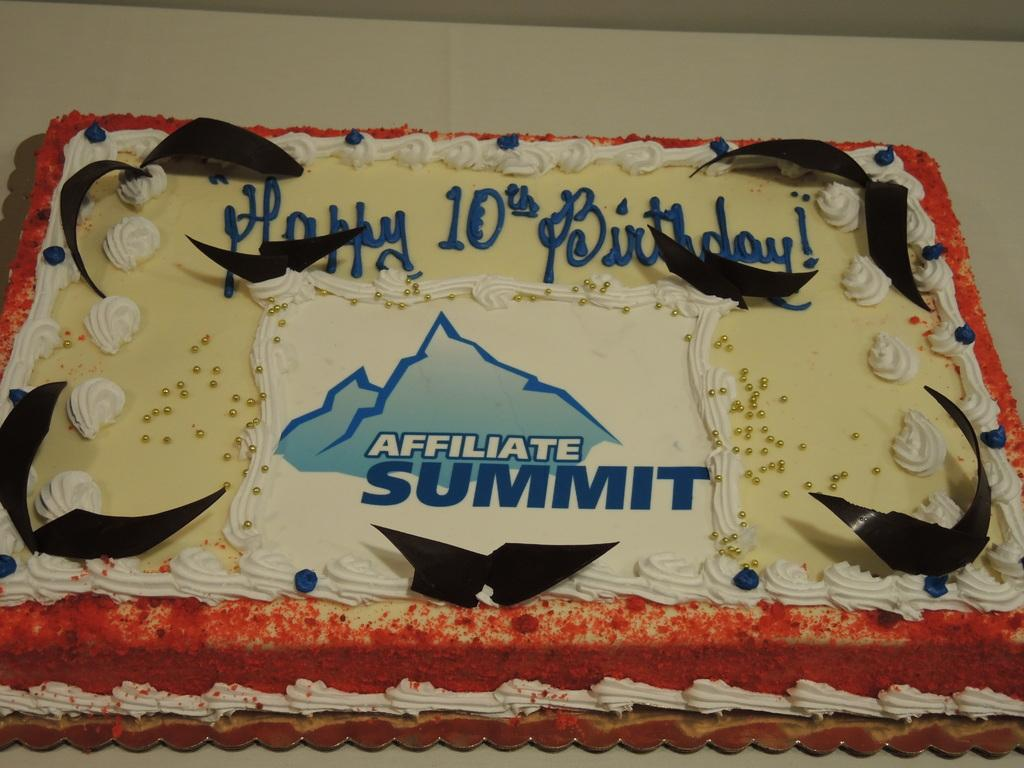What is the main subject of the image? There is a cake in the image. How is the cake decorated? The cake is decorated with different creams. What type of animal can be seen interacting with the cake in the image? There are no animals present in the image; it only features a cake decorated with different creams. Can you hear any thunder in the image? There is no sound or indication of thunder in the image, as it is a still image of a cake. 